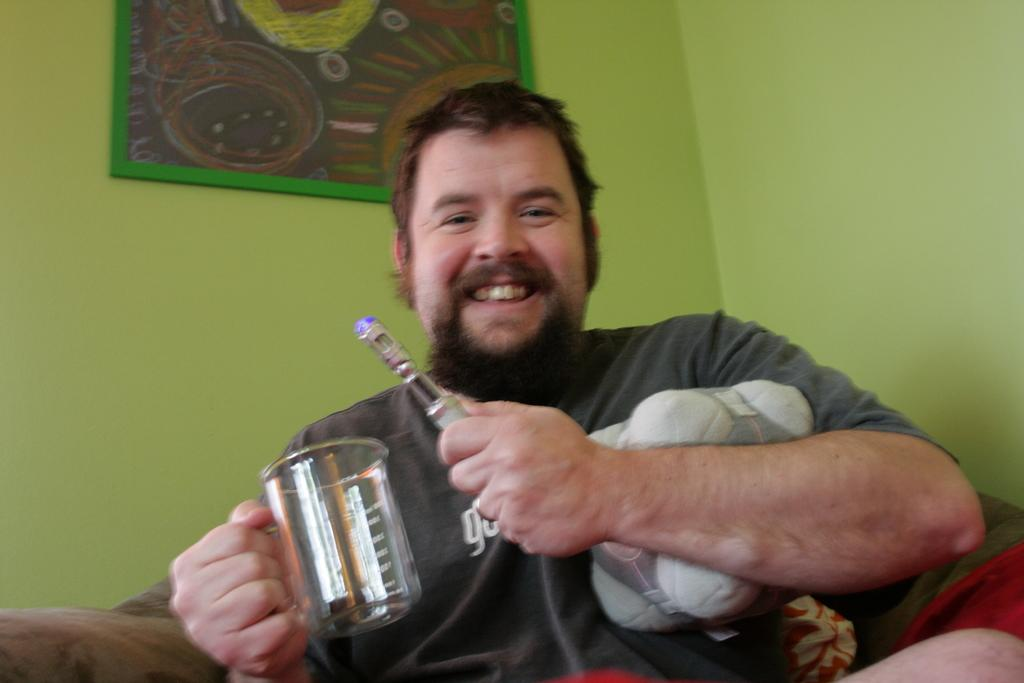Who is present in the image? There is a man in the image. What is the man holding in the image? The man is holding a mug. Where is the man sitting in the image? The man is sitting on a sofa. What color is the wall in the background of the image? There is a green-colored wall in the background. What can be seen on the wall in the image? There is a frame on the wall. Can you see any windows in the image? There is no window visible in the image; it only shows a man sitting on a sofa with a mug, a green-colored wall, and a frame on the wall. 